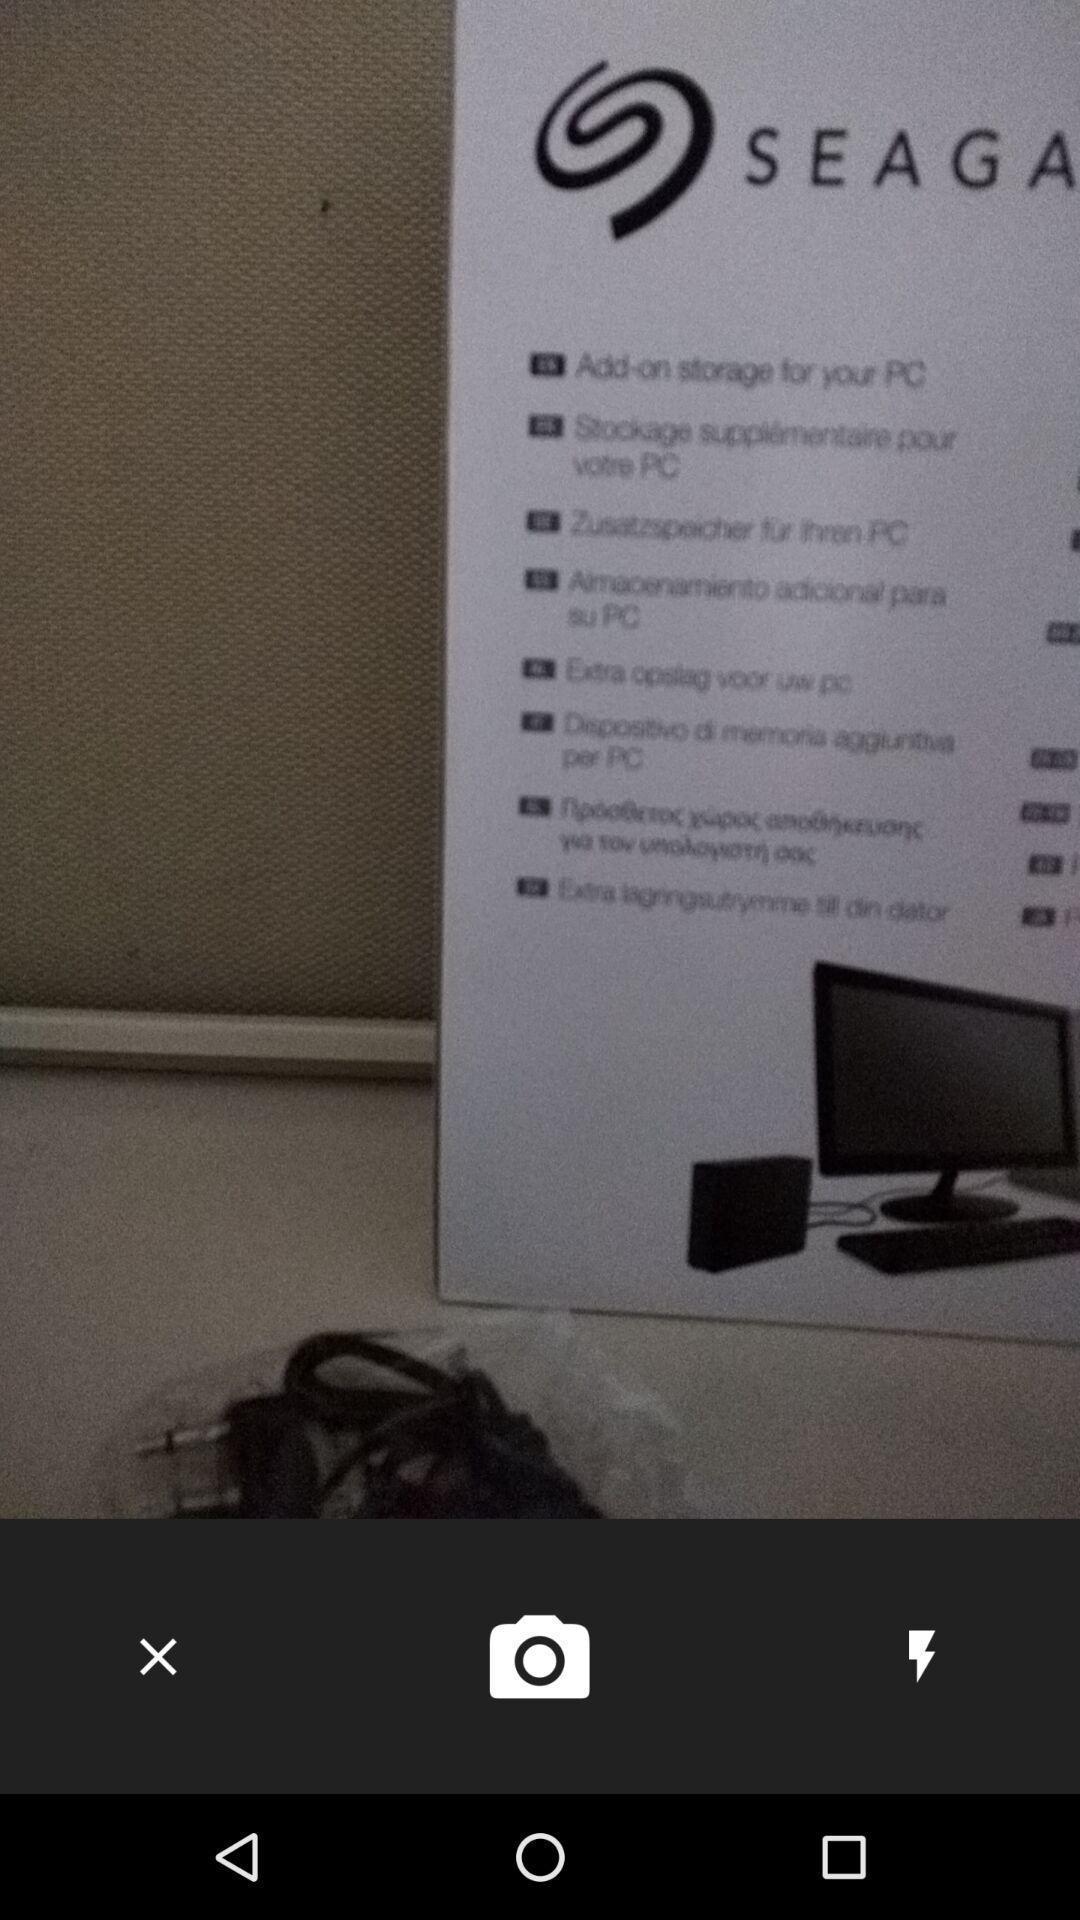Please provide a description for this image. Taking a picture from camera. 